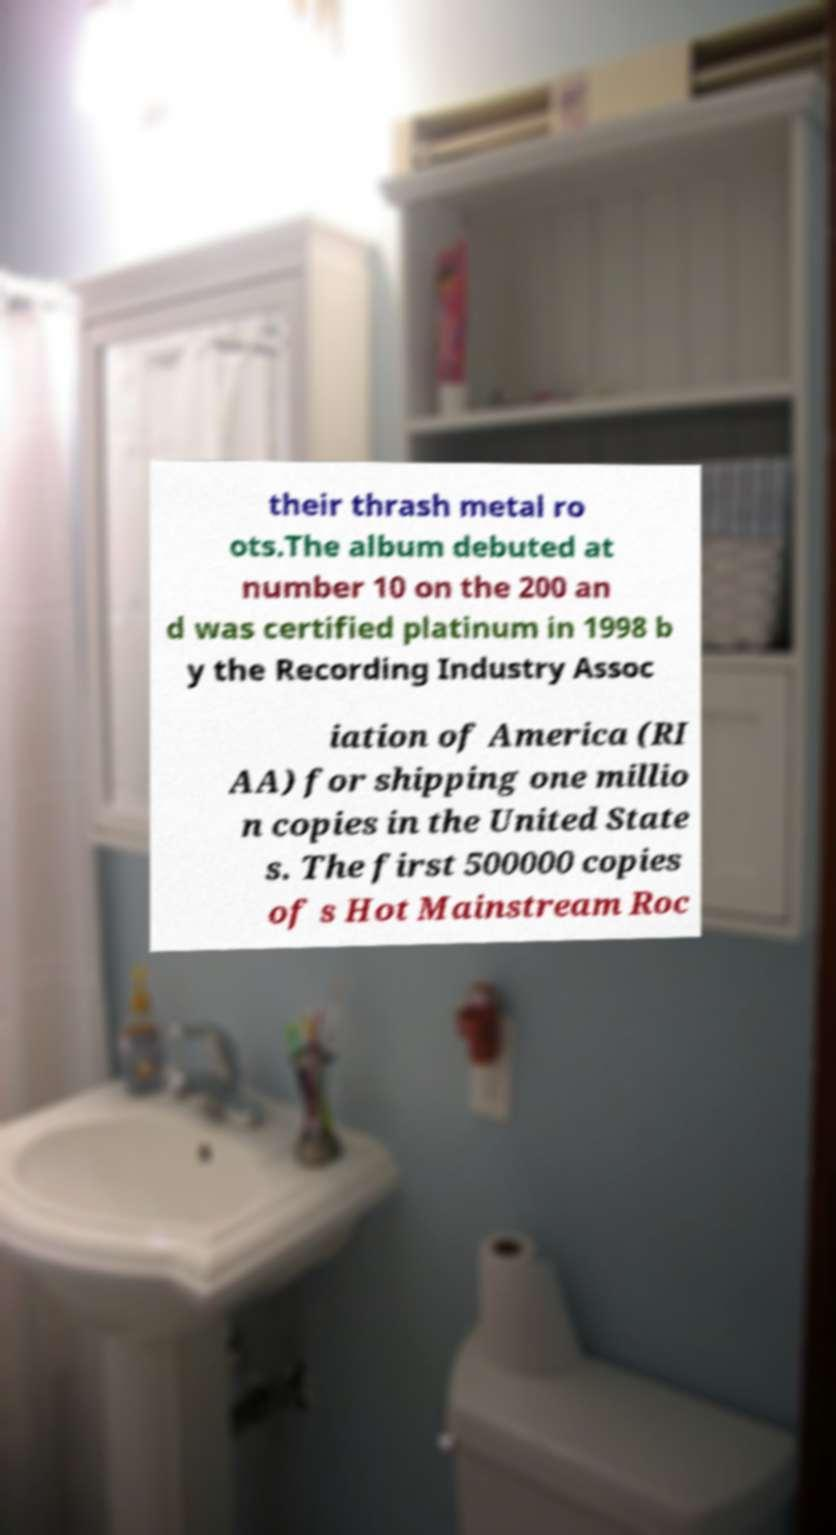What messages or text are displayed in this image? I need them in a readable, typed format. their thrash metal ro ots.The album debuted at number 10 on the 200 an d was certified platinum in 1998 b y the Recording Industry Assoc iation of America (RI AA) for shipping one millio n copies in the United State s. The first 500000 copies of s Hot Mainstream Roc 